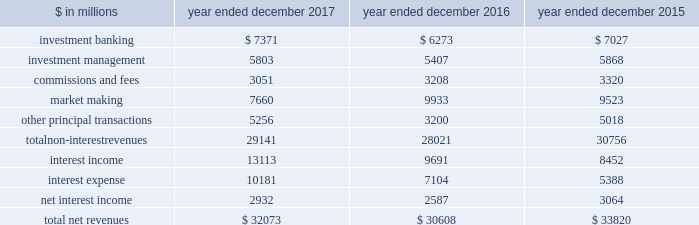The goldman sachs group , inc .
And subsidiaries management 2019s discussion and analysis net revenues the table below presents our net revenues by line item in the consolidated statements of earnings. .
In the table above : 2030 investment banking consists of revenues ( excluding net interest ) from financial advisory and underwriting assignments , as well as derivative transactions directly related to these assignments .
These activities are included in our investment banking segment .
2030 investment management consists of revenues ( excluding net interest ) from providing investment management services to a diverse set of clients , as well as wealth advisory services and certain transaction services to high-net-worth individuals and families .
These activities are included in our investment management segment .
2030 commissions and fees consists of revenues from executing and clearing client transactions on major stock , options and futures exchanges worldwide , as well as over-the-counter ( otc ) transactions .
These activities are included in our institutional client services and investment management segments .
2030 market making consists of revenues ( excluding net interest ) from client execution activities related to making markets in interest rate products , credit products , mortgages , currencies , commodities and equity products .
These activities are included in our institutional client services segment .
2030 other principal transactions consists of revenues ( excluding net interest ) from our investing activities and the origination of loans to provide financing to clients .
In addition , other principal transactions includes revenues related to our consolidated investments .
These activities are included in our investing & lending segment .
Operating environment .
During 2017 , generally higher asset prices and tighter credit spreads were supportive of industry-wide underwriting activities , investment management performance and other principal transactions .
However , low levels of volatility in equity , fixed income , currency and commodity markets continued to negatively affect our market-making activities , particularly in fixed income , currency and commodity products .
The price of natural gas decreased significantly during 2017 , while the price of oil increased compared with the end of 2016 .
If the trend of low volatility continues over the long term and market-making activity levels remain low , or if investment banking activity levels , asset prices or assets under supervision decline , net revenues would likely be negatively impacted .
See 201csegment operating results 201d below for further information about the operating environment and material trends and uncertainties that may impact our results of operations .
The first half of 2016 included challenging trends in the operating environment for our business activities including concerns and uncertainties about global economic growth , central bank activity and the political uncertainty and economic implications surrounding the potential exit of the u.k .
From the e.u .
During the second half of 2016 , the operating environment improved , as global equity markets steadily increased and investment grade and high-yield credit spreads tightened .
These trends provided a more favorable backdrop for our business activities .
2017 versus 2016 net revenues in the consolidated statements of earnings were $ 32.07 billion for 2017 , 5% ( 5 % ) higher than 2016 , due to significantly higher other principal transactions revenues , and higher investment banking revenues , investment management revenues and net interest income .
These increases were partially offset by significantly lower market making revenues and lower commissions and fees .
Non-interest revenues .
Investment banking revenues in the consolidated statements of earnings were $ 7.37 billion for 2017 , 18% ( 18 % ) higher than 2016 .
Revenues in financial advisory were higher compared with 2016 , reflecting an increase in completed mergers and acquisitions transactions .
Revenues in underwriting were significantly higher compared with 2016 , due to significantly higher revenues in both debt underwriting , primarily reflecting an increase in industry-wide leveraged finance activity , and equity underwriting , reflecting an increase in industry-wide secondary offerings .
52 goldman sachs 2017 form 10-k .
What is the growth rate in net revenues in 2016? 
Computations: ((30608 - 33820) / 33820)
Answer: -0.09497. 